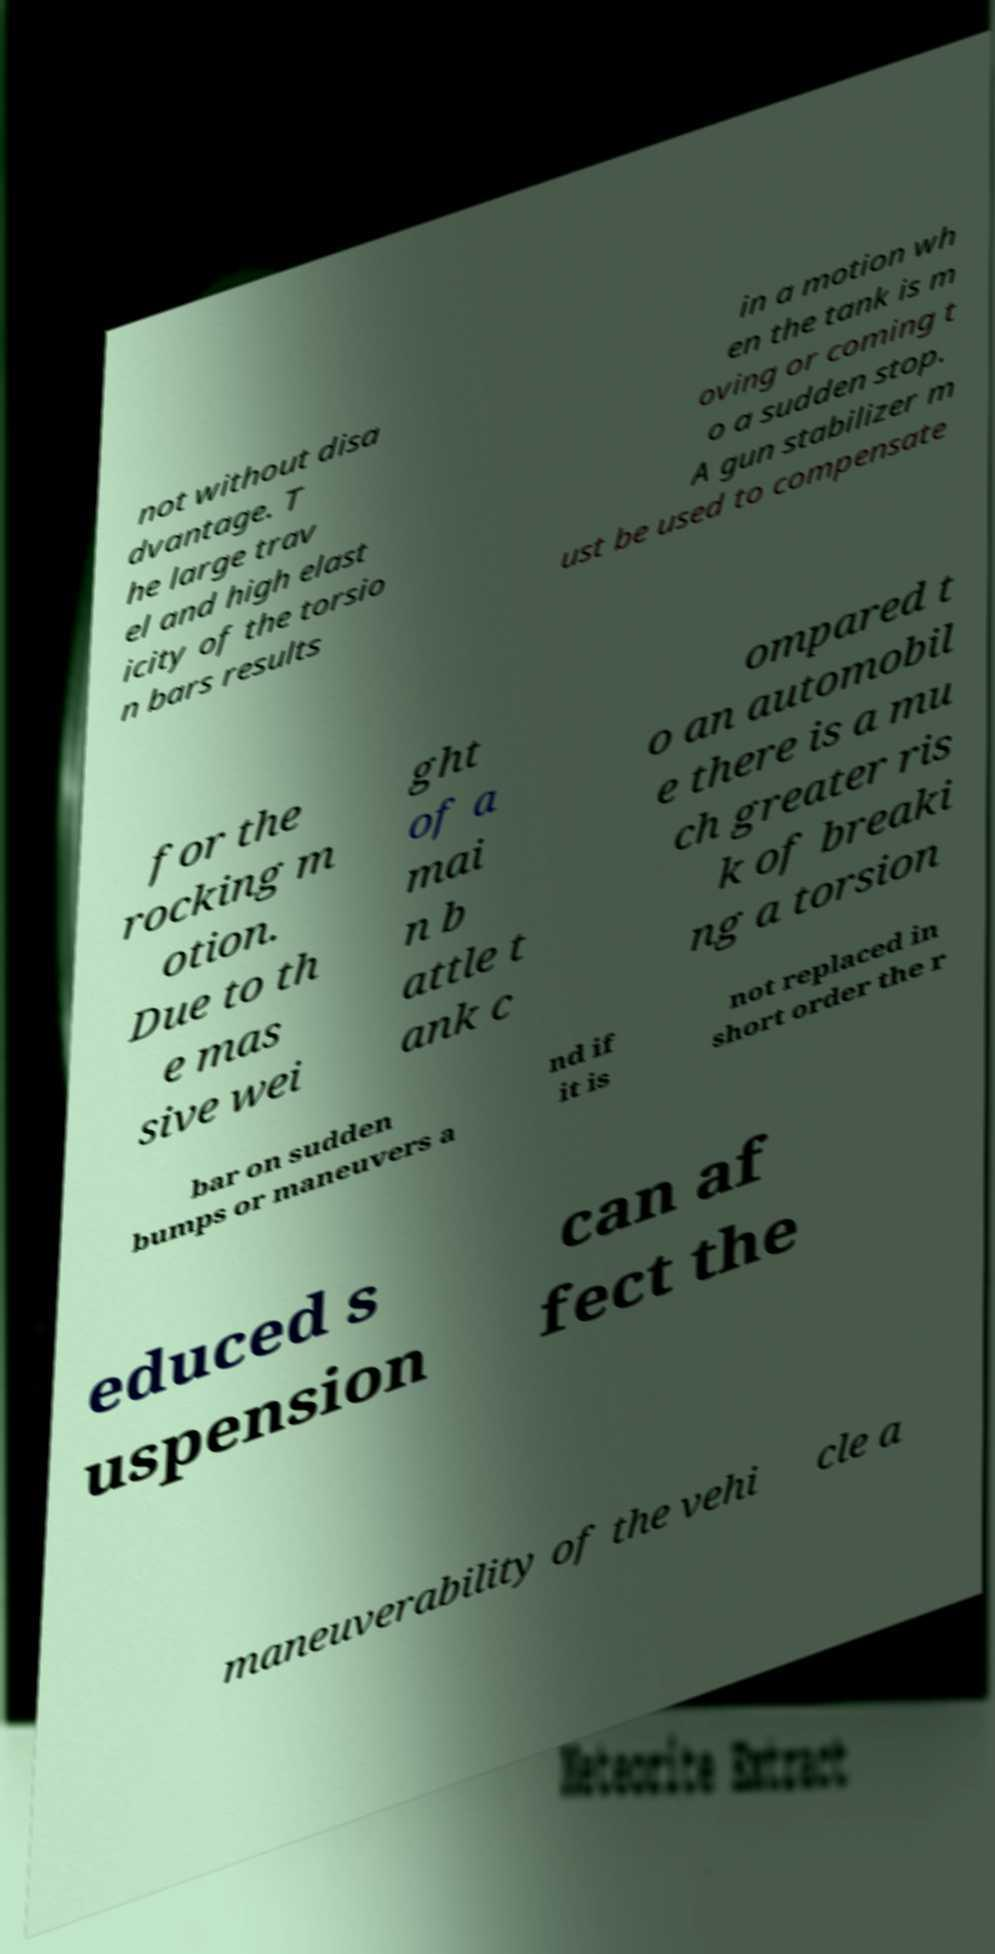Please identify and transcribe the text found in this image. not without disa dvantage. T he large trav el and high elast icity of the torsio n bars results in a motion wh en the tank is m oving or coming t o a sudden stop. A gun stabilizer m ust be used to compensate for the rocking m otion. Due to th e mas sive wei ght of a mai n b attle t ank c ompared t o an automobil e there is a mu ch greater ris k of breaki ng a torsion bar on sudden bumps or maneuvers a nd if it is not replaced in short order the r educed s uspension can af fect the maneuverability of the vehi cle a 